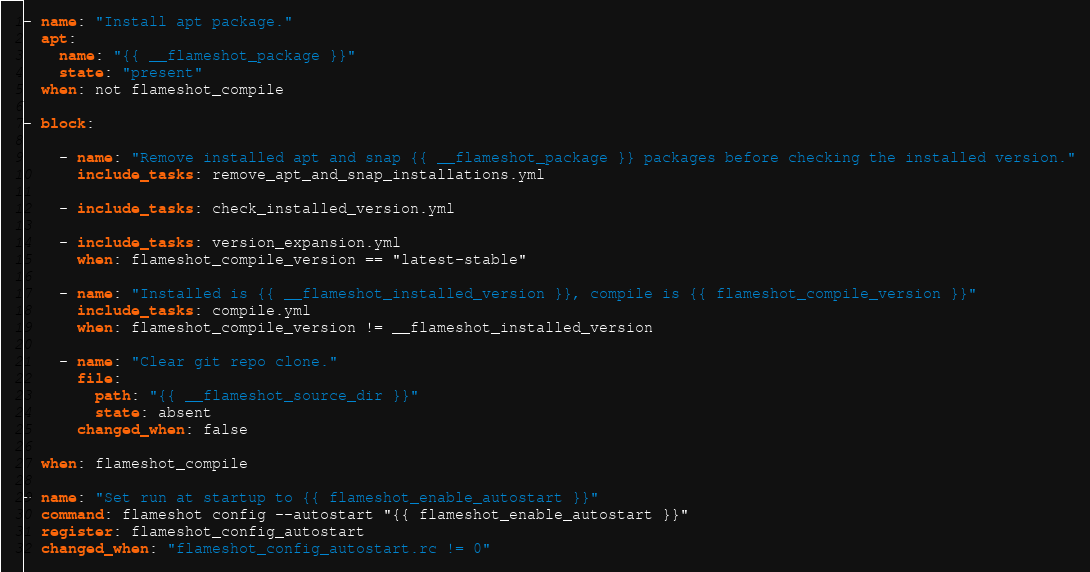Convert code to text. <code><loc_0><loc_0><loc_500><loc_500><_YAML_>
- name: "Install apt package."
  apt:
    name: "{{ __flameshot_package }}"
    state: "present"
  when: not flameshot_compile

- block:

    - name: "Remove installed apt and snap {{ __flameshot_package }} packages before checking the installed version."
      include_tasks: remove_apt_and_snap_installations.yml

    - include_tasks: check_installed_version.yml

    - include_tasks: version_expansion.yml
      when: flameshot_compile_version == "latest-stable"

    - name: "Installed is {{ __flameshot_installed_version }}, compile is {{ flameshot_compile_version }}"
      include_tasks: compile.yml
      when: flameshot_compile_version != __flameshot_installed_version

    - name: "Clear git repo clone."
      file:
        path: "{{ __flameshot_source_dir }}"
        state: absent
      changed_when: false

  when: flameshot_compile

- name: "Set run at startup to {{ flameshot_enable_autostart }}"
  command: flameshot config --autostart "{{ flameshot_enable_autostart }}"
  register: flameshot_config_autostart
  changed_when: "flameshot_config_autostart.rc != 0"
</code> 